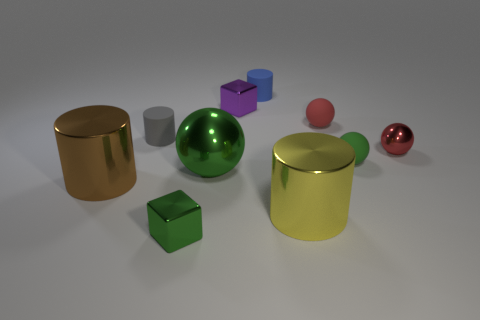Is the shape of the small red rubber thing the same as the large metallic thing behind the big brown shiny cylinder?
Your answer should be compact. Yes. How many things are either blue rubber objects behind the purple shiny object or shiny things that are right of the large green object?
Keep it short and to the point. 4. Are there fewer red rubber objects left of the big yellow metal cylinder than large brown metallic things?
Provide a short and direct response. Yes. Do the gray cylinder and the tiny green thing to the right of the blue rubber object have the same material?
Give a very brief answer. Yes. What material is the purple object?
Make the answer very short. Metal. The green object to the right of the large shiny thing on the right side of the big green shiny thing that is left of the big yellow metallic object is made of what material?
Give a very brief answer. Rubber. There is a small metal sphere; does it have the same color as the tiny matte sphere behind the small red metallic thing?
Your answer should be compact. Yes. There is a big object that is on the left side of the small green thing on the left side of the yellow object; what is its color?
Your response must be concise. Brown. How many small red balls are there?
Ensure brevity in your answer.  2. How many metallic things are spheres or tiny cyan balls?
Your answer should be very brief. 2. 